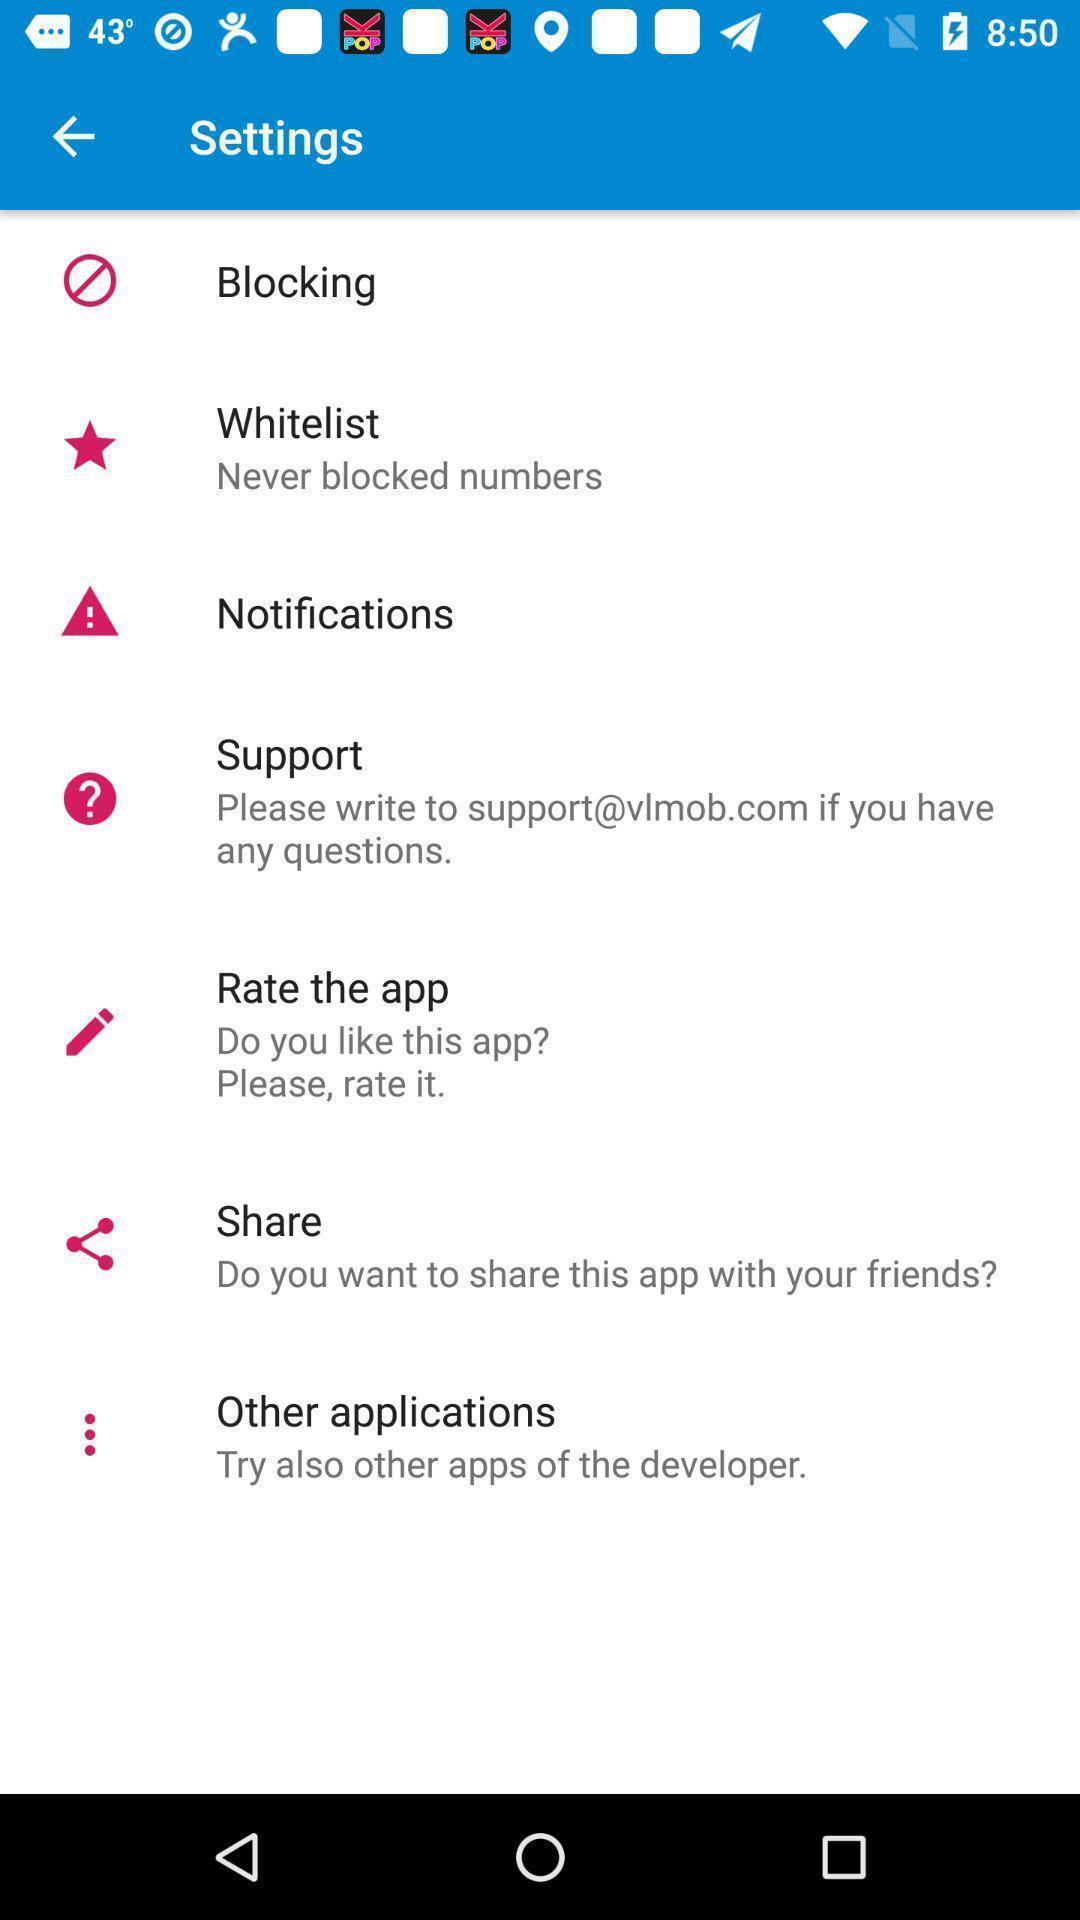Describe this image in words. Screen shows a general settings on an android. 